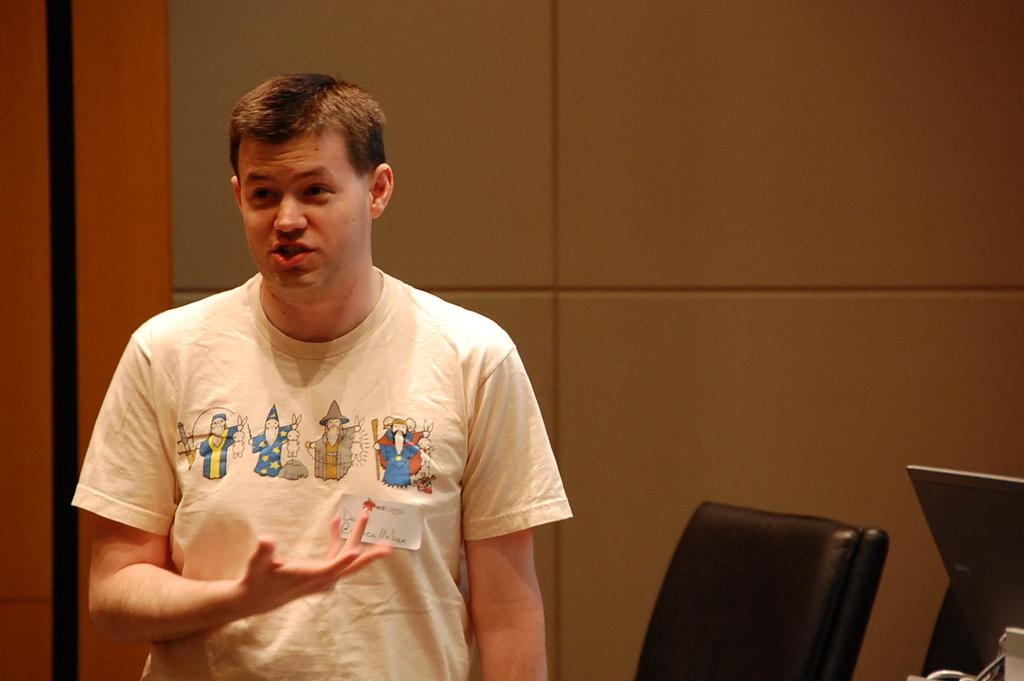What is the main subject of the image? There is a man standing in the image. What is the man wearing? The man is wearing clothes. What can be seen in the background of the image? There is a wall in the image. Are there any other objects or items in the image? Yes, there are objects in the image. Can you describe something unusual about the man's clothing? There is a piece of paper stuck to the man's T-shirt. What type of story is being told by the flame in the image? There is no flame present in the image, so it is not possible to answer that question. 